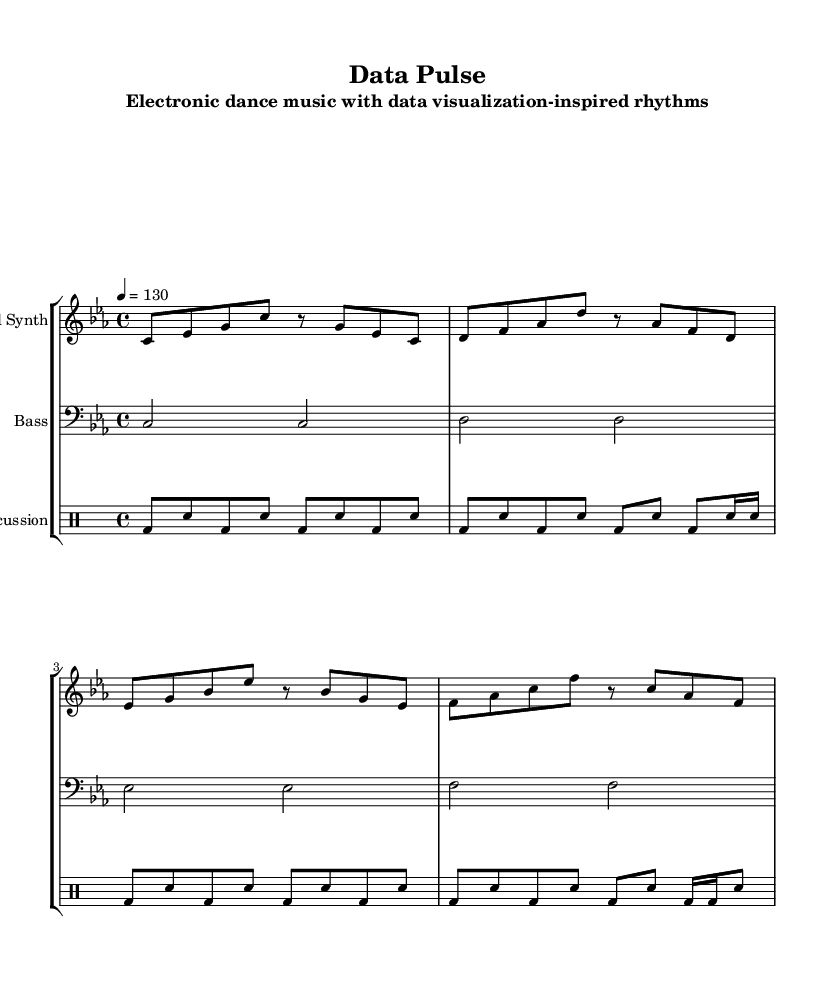What is the key signature of this music? The key signature is C minor, which consists of three flats: B flat, E flat, and A flat. This can be determined from the key signature indicated in the staff at the beginning of the music.
Answer: C minor What is the time signature of this music? The time signature is 4/4, which indicates that there are four beats in each measure and a quarter note receives one beat. This is represented at the beginning of the score next to the key signature.
Answer: 4/4 What is the tempo marking of the piece? The tempo marking is given as quarter note equals 130, meaning the piece should be played at 130 beats per minute. This tempo indication is found in the global variable declaration in the score.
Answer: 130 How many measures are there in the lead synth part? There are a total of four measures in the lead synth part as shown in the notes grouped into a standard measure length, with each line comprising four measures.
Answer: 4 What type of rhythmic pattern does the percussion section primarily use? The percussion section primarily uses an alternating bass drum and snare pattern, highlighted by the consistent high and low sounds in an eighth note rhythm. This is visible in the notation of the percussion part throughout the measures.
Answer: Alternating bass and snare What is the relationship between the lead synth and bass? The lead synth plays a melodic line while the bass provides a harmonic foundation by playing longer notes. This is shown in the score where the lead synth has eighth notes while the bass plays whole notes over the same measures.
Answer: Melodic and harmonic How does the tempo affect the energy of this electronic dance music? The tempo of 130 beats per minute in this piece contributes to a driving and energetic feel typical of electronic dance music, as faster tempos create a sense of urgency and encourage movement on the dance floor. This is common in dance music styles.
Answer: Energetic 